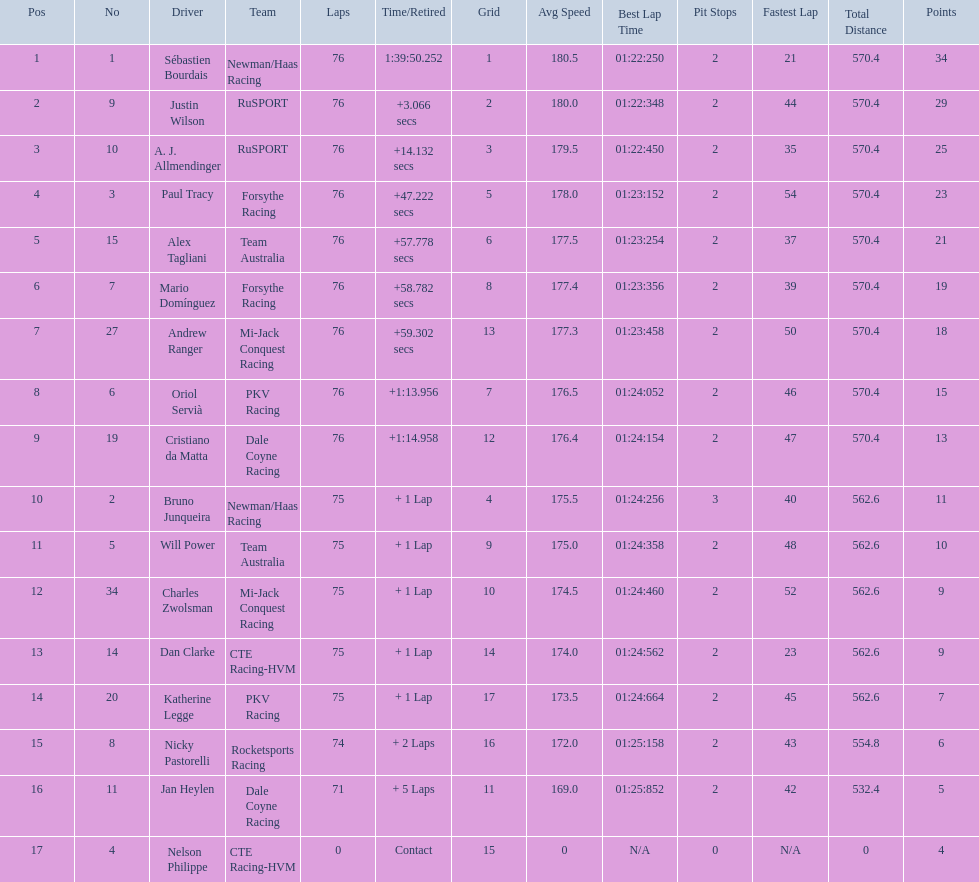Which drivers completed all 76 laps? Sébastien Bourdais, Justin Wilson, A. J. Allmendinger, Paul Tracy, Alex Tagliani, Mario Domínguez, Andrew Ranger, Oriol Servià, Cristiano da Matta. Of these drivers, which ones finished less than a minute behind first place? Paul Tracy, Alex Tagliani, Mario Domínguez, Andrew Ranger. Of these drivers, which ones finished with a time less than 50 seconds behind first place? Justin Wilson, A. J. Allmendinger, Paul Tracy. Of these three drivers, who finished last? Paul Tracy. 